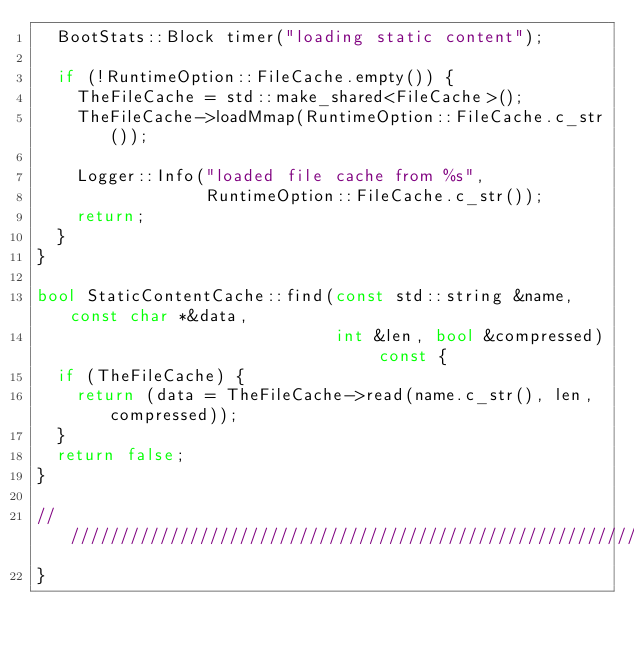<code> <loc_0><loc_0><loc_500><loc_500><_C++_>  BootStats::Block timer("loading static content");

  if (!RuntimeOption::FileCache.empty()) {
    TheFileCache = std::make_shared<FileCache>();
    TheFileCache->loadMmap(RuntimeOption::FileCache.c_str());

    Logger::Info("loaded file cache from %s",
                 RuntimeOption::FileCache.c_str());
    return;
  }
}

bool StaticContentCache::find(const std::string &name, const char *&data,
                              int &len, bool &compressed) const {
  if (TheFileCache) {
    return (data = TheFileCache->read(name.c_str(), len, compressed));
  }
  return false;
}

///////////////////////////////////////////////////////////////////////////////
}
</code> 